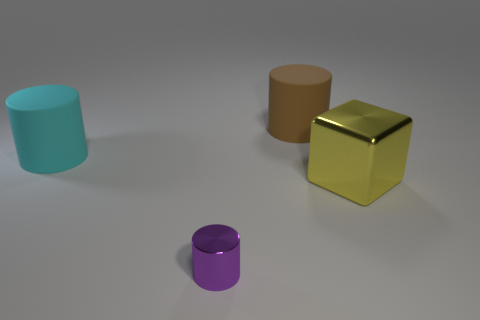Add 4 cubes. How many objects exist? 8 Subtract all big brown cylinders. How many cylinders are left? 2 Subtract all cyan cylinders. How many cylinders are left? 2 Subtract 1 cylinders. How many cylinders are left? 2 Subtract all cyan cylinders. Subtract all yellow cubes. How many cylinders are left? 2 Subtract all brown cylinders. Subtract all large objects. How many objects are left? 0 Add 2 brown matte cylinders. How many brown matte cylinders are left? 3 Add 3 tiny green rubber cylinders. How many tiny green rubber cylinders exist? 3 Subtract 0 green cubes. How many objects are left? 4 Subtract all cylinders. How many objects are left? 1 